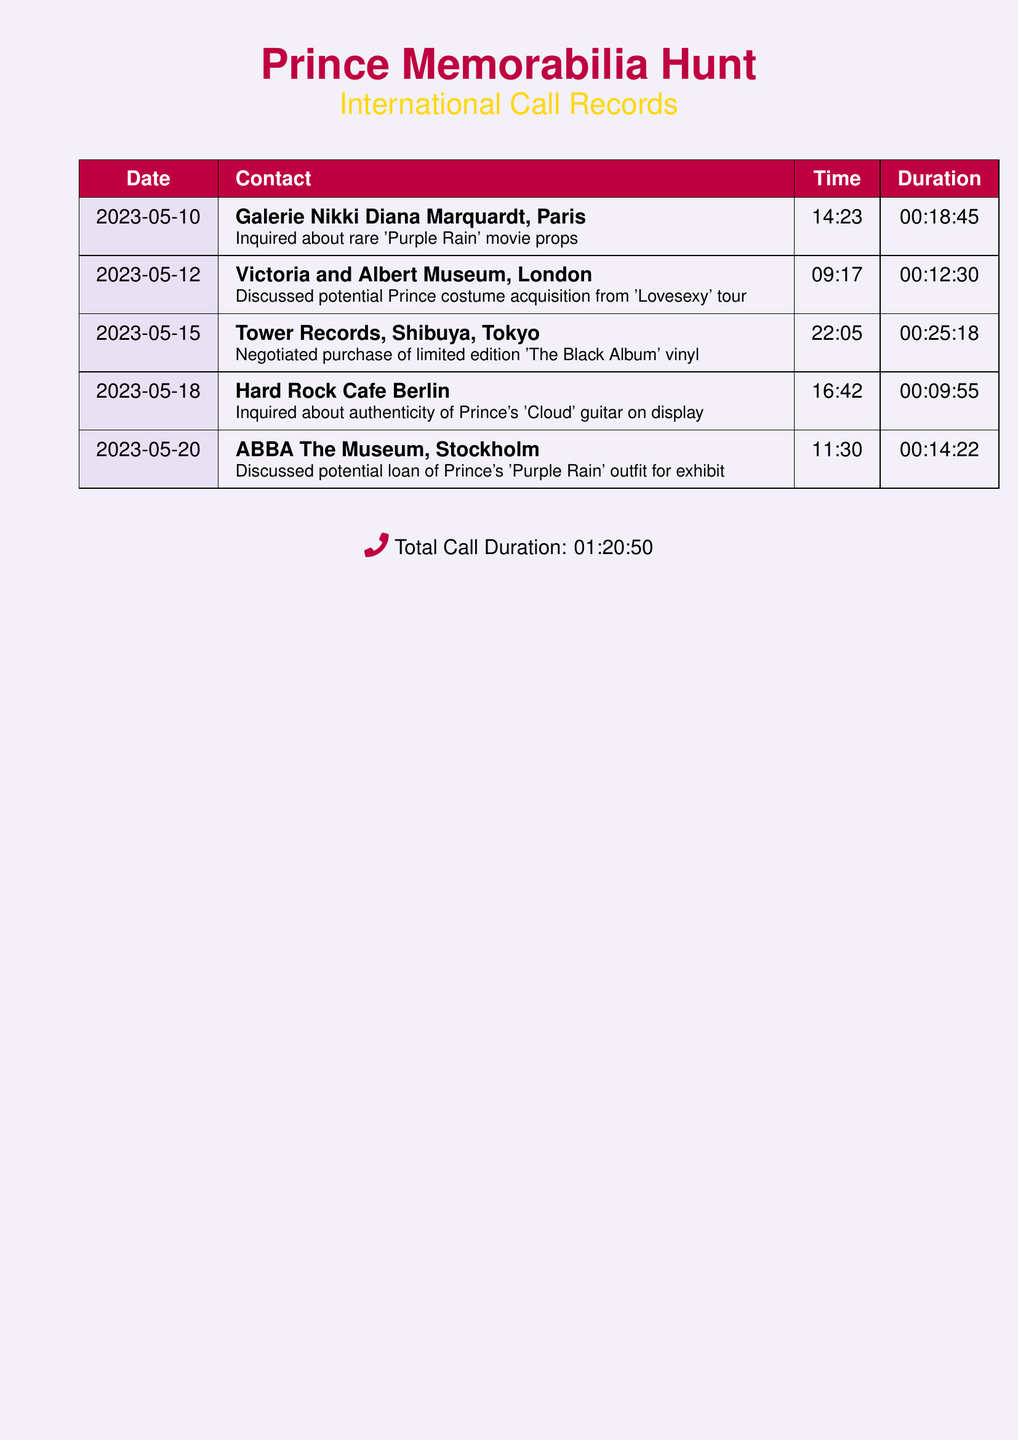What is the date of the call to Galerie Nikki Diana Marquardt? The date listed for the call to Galerie Nikki Diana Marquardt is in the first row of the table, which is 2023-05-10.
Answer: 2023-05-10 What time was the call made to Tower Records? The time for the call made to Tower Records is located in the row corresponding to Tower Records, which is 22:05.
Answer: 22:05 How long was the call discussing the authenticity of Prince's 'Cloud' guitar? The duration of the call to Hard Rock Cafe Berlin regarding the authenticity of the guitar is found in that row, which is 00:09:55.
Answer: 00:09:55 Which museum was discussed for a potential loan of Prince's 'Purple Rain' outfit? The museum mentioned for the potential loan of the outfit is in the relevant row, which is ABBA The Museum, Stockholm.
Answer: ABBA The Museum, Stockholm What is the total call duration? The total call duration is mentioned in the final summary of the document, which amounts to a total of 01:20:50.
Answer: 01:20:50 Which call had the longest duration? The call with the longest duration can be determined by comparing all durations, which is the call to Tower Records at 00:25:18.
Answer: 00:25:18 How many calls were made in total? The total number of calls is indicated by the number of rows in the document, which is 5.
Answer: 5 What kind of memorabilia was inquired about during the call to the Victoria and Albert Museum? The inquiry to the Victoria and Albert Museum was about a Prince costume, which is specified in that row.
Answer: Prince costume Which city is Tower Records located in? The location of Tower Records is specified in the call entry, which is Shibuya, Tokyo.
Answer: Shibuya, Tokyo 